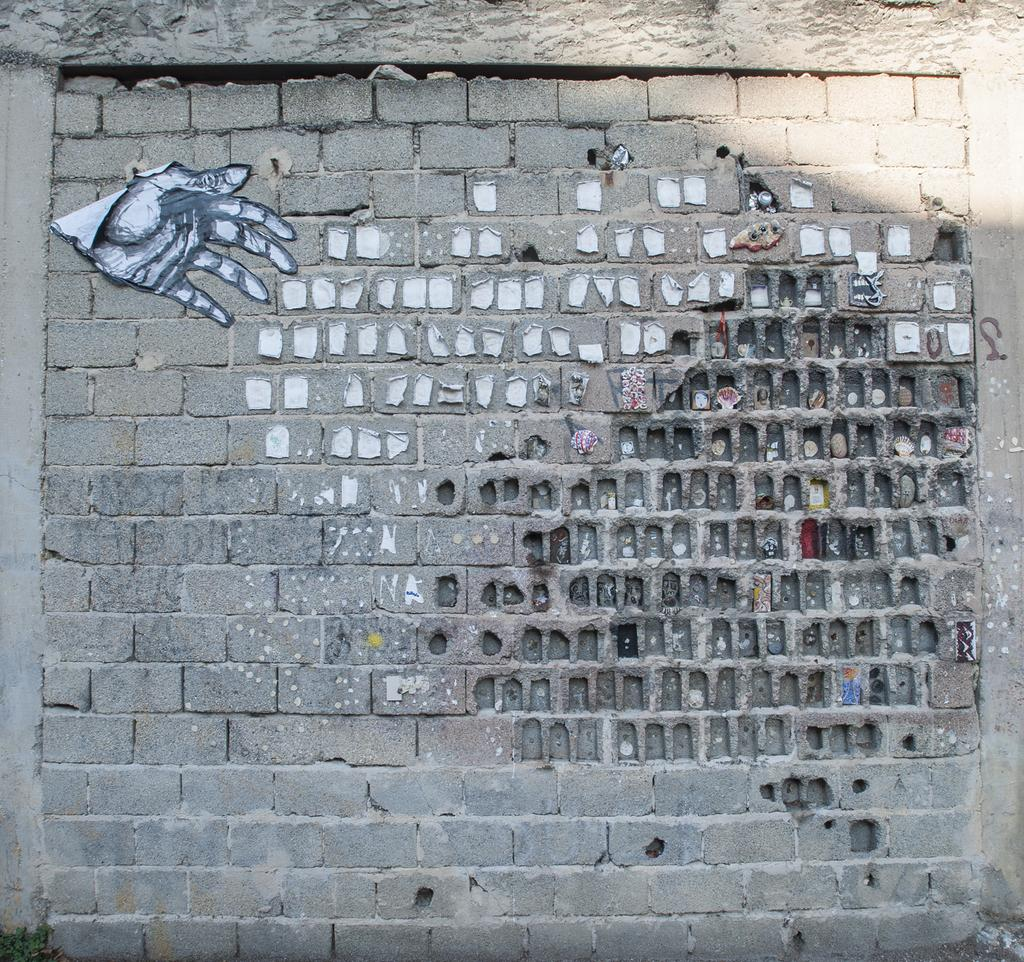What is one of the main features of the image? There is a wall in the image. What can be seen on the wall? The wall has stickers on it. Can you describe any other objects or features in the image? There are objects present in the image, but their specific details are not mentioned in the provided facts. What type of spark can be seen coming from the wall in the image? There is no spark present in the image; the wall has stickers on it. What type of education can be seen being provided in the image? There is no indication of education or any educational activity in the image. 